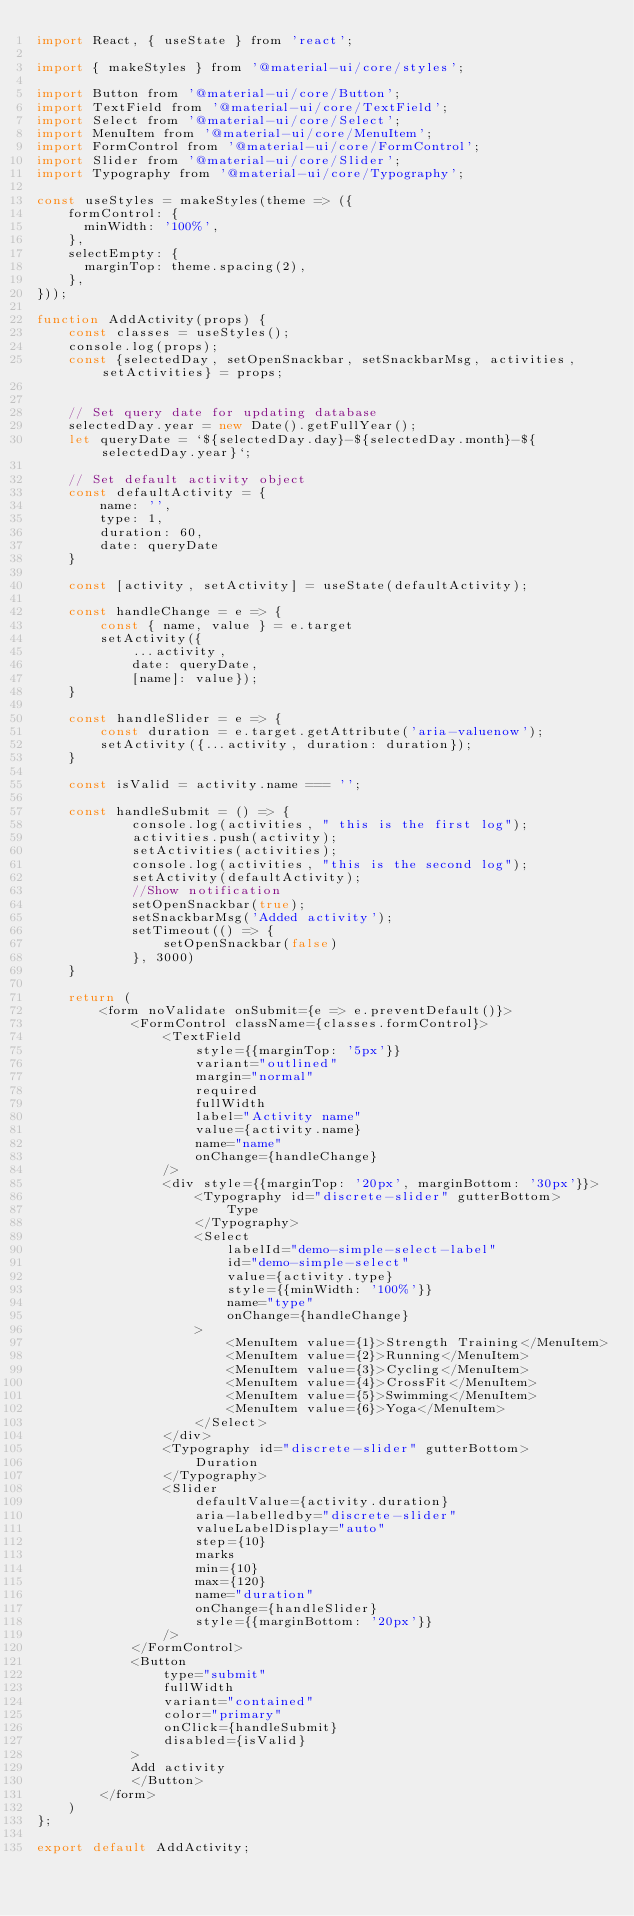<code> <loc_0><loc_0><loc_500><loc_500><_JavaScript_>import React, { useState } from 'react';

import { makeStyles } from '@material-ui/core/styles';

import Button from '@material-ui/core/Button';
import TextField from '@material-ui/core/TextField';
import Select from '@material-ui/core/Select';
import MenuItem from '@material-ui/core/MenuItem';
import FormControl from '@material-ui/core/FormControl';
import Slider from '@material-ui/core/Slider';
import Typography from '@material-ui/core/Typography';

const useStyles = makeStyles(theme => ({
    formControl: {
      minWidth: '100%',
    },
    selectEmpty: {
      marginTop: theme.spacing(2),
    },
}));

function AddActivity(props) {
    const classes = useStyles();
    console.log(props); 
    const {selectedDay, setOpenSnackbar, setSnackbarMsg, activities, setActivities} = props;
    

    // Set query date for updating database
    selectedDay.year = new Date().getFullYear();
    let queryDate = `${selectedDay.day}-${selectedDay.month}-${selectedDay.year}`;

    // Set default activity object
    const defaultActivity = {
        name: '',
        type: 1,
        duration: 60,
        date: queryDate
    }

    const [activity, setActivity] = useState(defaultActivity);

    const handleChange = e => {
        const { name, value } = e.target 
        setActivity({
            ...activity, 
            date: queryDate,
            [name]: value});
    }

    const handleSlider = e => {
        const duration = e.target.getAttribute('aria-valuenow');
        setActivity({...activity, duration: duration});
    }

    const isValid = activity.name === '';
   
    const handleSubmit = () => {
            console.log(activities, " this is the first log");
            activities.push(activity); 
            setActivities(activities); 
            console.log(activities, "this is the second log");
            setActivity(defaultActivity);
            //Show notification
            setOpenSnackbar(true);
            setSnackbarMsg('Added activity');
            setTimeout(() => {
                setOpenSnackbar(false)
            }, 3000)
    }

    return (
        <form noValidate onSubmit={e => e.preventDefault()}>
            <FormControl className={classes.formControl}>
                <TextField
                    style={{marginTop: '5px'}}
                    variant="outlined"
                    margin="normal"
                    required
                    fullWidth
                    label="Activity name"
                    value={activity.name}
                    name="name"
                    onChange={handleChange}
                />
                <div style={{marginTop: '20px', marginBottom: '30px'}}>
                    <Typography id="discrete-slider" gutterBottom>
                        Type
                    </Typography>
                    <Select
                        labelId="demo-simple-select-label"
                        id="demo-simple-select"
                        value={activity.type}
                        style={{minWidth: '100%'}}
                        name="type"
                        onChange={handleChange}
                    >
                        <MenuItem value={1}>Strength Training</MenuItem>
                        <MenuItem value={2}>Running</MenuItem>
                        <MenuItem value={3}>Cycling</MenuItem>
                        <MenuItem value={4}>CrossFit</MenuItem> 
                        <MenuItem value={5}>Swimming</MenuItem>
                        <MenuItem value={6}>Yoga</MenuItem>
                    </Select>
                </div>
                <Typography id="discrete-slider" gutterBottom>
                    Duration
                </Typography>
                <Slider
                    defaultValue={activity.duration}
                    aria-labelledby="discrete-slider"
                    valueLabelDisplay="auto"
                    step={10}
                    marks
                    min={10}
                    max={120}
                    name="duration"
                    onChange={handleSlider}
                    style={{marginBottom: '20px'}}
                />
            </FormControl>
            <Button
                type="submit"
                fullWidth
                variant="contained"
                color="primary"
                onClick={handleSubmit}
                disabled={isValid}
            >
            Add activity
            </Button>
        </form>
    )
};

export default AddActivity;</code> 